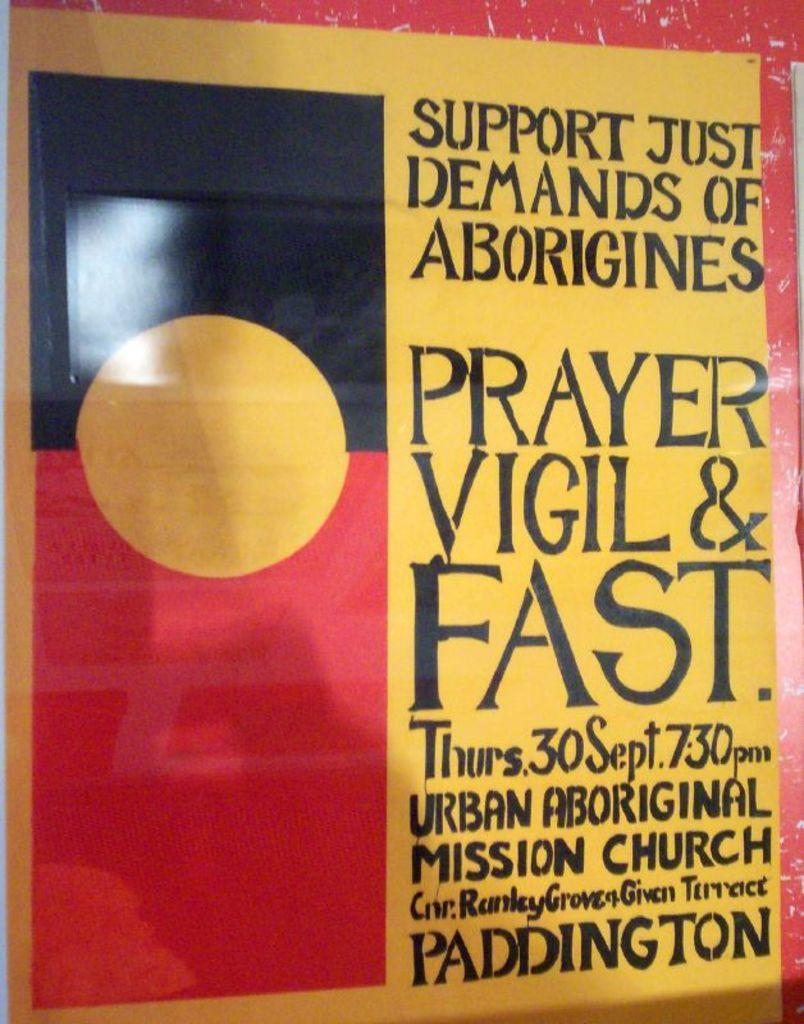<image>
Describe the image concisely. "Supporting Aborigines through prayer" is written on this poster. 